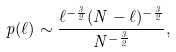<formula> <loc_0><loc_0><loc_500><loc_500>p ( \ell ) \sim \frac { \ell ^ { - \frac { 3 } { 2 } } ( N - \ell ) ^ { - \frac { 3 } { 2 } } } { N ^ { - \frac { 3 } { 2 } } } ,</formula> 